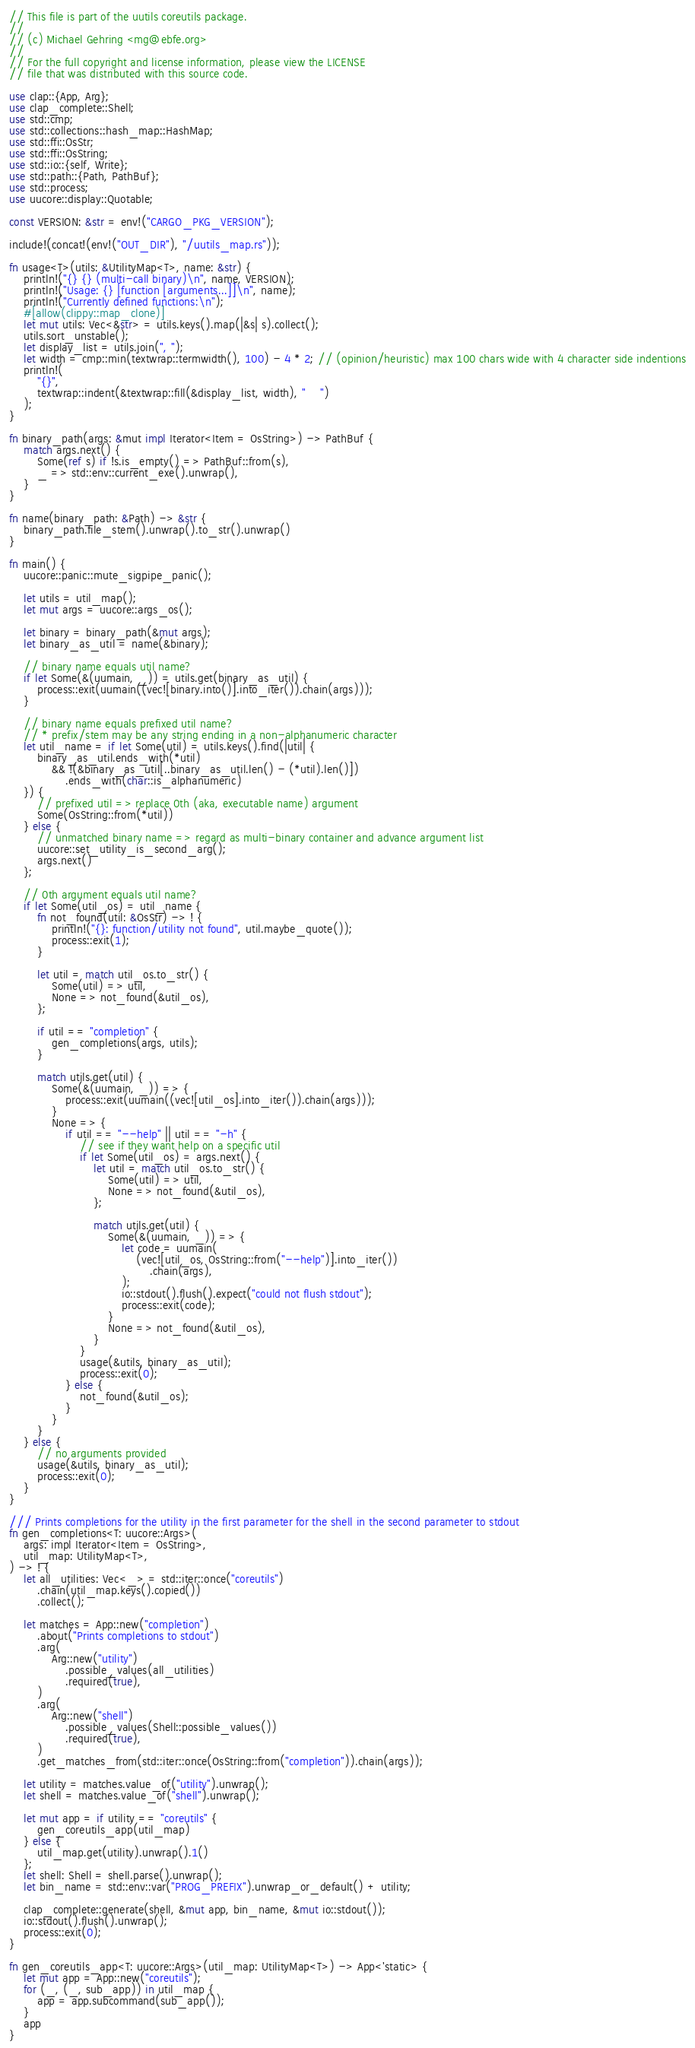<code> <loc_0><loc_0><loc_500><loc_500><_Rust_>// This file is part of the uutils coreutils package.
//
// (c) Michael Gehring <mg@ebfe.org>
//
// For the full copyright and license information, please view the LICENSE
// file that was distributed with this source code.

use clap::{App, Arg};
use clap_complete::Shell;
use std::cmp;
use std::collections::hash_map::HashMap;
use std::ffi::OsStr;
use std::ffi::OsString;
use std::io::{self, Write};
use std::path::{Path, PathBuf};
use std::process;
use uucore::display::Quotable;

const VERSION: &str = env!("CARGO_PKG_VERSION");

include!(concat!(env!("OUT_DIR"), "/uutils_map.rs"));

fn usage<T>(utils: &UtilityMap<T>, name: &str) {
    println!("{} {} (multi-call binary)\n", name, VERSION);
    println!("Usage: {} [function [arguments...]]\n", name);
    println!("Currently defined functions:\n");
    #[allow(clippy::map_clone)]
    let mut utils: Vec<&str> = utils.keys().map(|&s| s).collect();
    utils.sort_unstable();
    let display_list = utils.join(", ");
    let width = cmp::min(textwrap::termwidth(), 100) - 4 * 2; // (opinion/heuristic) max 100 chars wide with 4 character side indentions
    println!(
        "{}",
        textwrap::indent(&textwrap::fill(&display_list, width), "    ")
    );
}

fn binary_path(args: &mut impl Iterator<Item = OsString>) -> PathBuf {
    match args.next() {
        Some(ref s) if !s.is_empty() => PathBuf::from(s),
        _ => std::env::current_exe().unwrap(),
    }
}

fn name(binary_path: &Path) -> &str {
    binary_path.file_stem().unwrap().to_str().unwrap()
}

fn main() {
    uucore::panic::mute_sigpipe_panic();

    let utils = util_map();
    let mut args = uucore::args_os();

    let binary = binary_path(&mut args);
    let binary_as_util = name(&binary);

    // binary name equals util name?
    if let Some(&(uumain, _)) = utils.get(binary_as_util) {
        process::exit(uumain((vec![binary.into()].into_iter()).chain(args)));
    }

    // binary name equals prefixed util name?
    // * prefix/stem may be any string ending in a non-alphanumeric character
    let util_name = if let Some(util) = utils.keys().find(|util| {
        binary_as_util.ends_with(*util)
            && !(&binary_as_util[..binary_as_util.len() - (*util).len()])
                .ends_with(char::is_alphanumeric)
    }) {
        // prefixed util => replace 0th (aka, executable name) argument
        Some(OsString::from(*util))
    } else {
        // unmatched binary name => regard as multi-binary container and advance argument list
        uucore::set_utility_is_second_arg();
        args.next()
    };

    // 0th argument equals util name?
    if let Some(util_os) = util_name {
        fn not_found(util: &OsStr) -> ! {
            println!("{}: function/utility not found", util.maybe_quote());
            process::exit(1);
        }

        let util = match util_os.to_str() {
            Some(util) => util,
            None => not_found(&util_os),
        };

        if util == "completion" {
            gen_completions(args, utils);
        }

        match utils.get(util) {
            Some(&(uumain, _)) => {
                process::exit(uumain((vec![util_os].into_iter()).chain(args)));
            }
            None => {
                if util == "--help" || util == "-h" {
                    // see if they want help on a specific util
                    if let Some(util_os) = args.next() {
                        let util = match util_os.to_str() {
                            Some(util) => util,
                            None => not_found(&util_os),
                        };

                        match utils.get(util) {
                            Some(&(uumain, _)) => {
                                let code = uumain(
                                    (vec![util_os, OsString::from("--help")].into_iter())
                                        .chain(args),
                                );
                                io::stdout().flush().expect("could not flush stdout");
                                process::exit(code);
                            }
                            None => not_found(&util_os),
                        }
                    }
                    usage(&utils, binary_as_util);
                    process::exit(0);
                } else {
                    not_found(&util_os);
                }
            }
        }
    } else {
        // no arguments provided
        usage(&utils, binary_as_util);
        process::exit(0);
    }
}

/// Prints completions for the utility in the first parameter for the shell in the second parameter to stdout
fn gen_completions<T: uucore::Args>(
    args: impl Iterator<Item = OsString>,
    util_map: UtilityMap<T>,
) -> ! {
    let all_utilities: Vec<_> = std::iter::once("coreutils")
        .chain(util_map.keys().copied())
        .collect();

    let matches = App::new("completion")
        .about("Prints completions to stdout")
        .arg(
            Arg::new("utility")
                .possible_values(all_utilities)
                .required(true),
        )
        .arg(
            Arg::new("shell")
                .possible_values(Shell::possible_values())
                .required(true),
        )
        .get_matches_from(std::iter::once(OsString::from("completion")).chain(args));

    let utility = matches.value_of("utility").unwrap();
    let shell = matches.value_of("shell").unwrap();

    let mut app = if utility == "coreutils" {
        gen_coreutils_app(util_map)
    } else {
        util_map.get(utility).unwrap().1()
    };
    let shell: Shell = shell.parse().unwrap();
    let bin_name = std::env::var("PROG_PREFIX").unwrap_or_default() + utility;

    clap_complete::generate(shell, &mut app, bin_name, &mut io::stdout());
    io::stdout().flush().unwrap();
    process::exit(0);
}

fn gen_coreutils_app<T: uucore::Args>(util_map: UtilityMap<T>) -> App<'static> {
    let mut app = App::new("coreutils");
    for (_, (_, sub_app)) in util_map {
        app = app.subcommand(sub_app());
    }
    app
}
</code> 